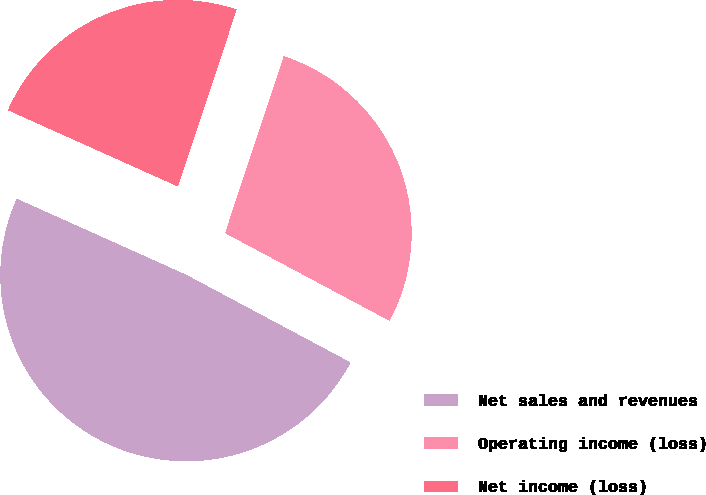Convert chart. <chart><loc_0><loc_0><loc_500><loc_500><pie_chart><fcel>Net sales and revenues<fcel>Operating income (loss)<fcel>Net income (loss)<nl><fcel>48.92%<fcel>27.71%<fcel>23.38%<nl></chart> 